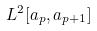Convert formula to latex. <formula><loc_0><loc_0><loc_500><loc_500>L ^ { 2 } [ a _ { p } , a _ { p + 1 } ]</formula> 